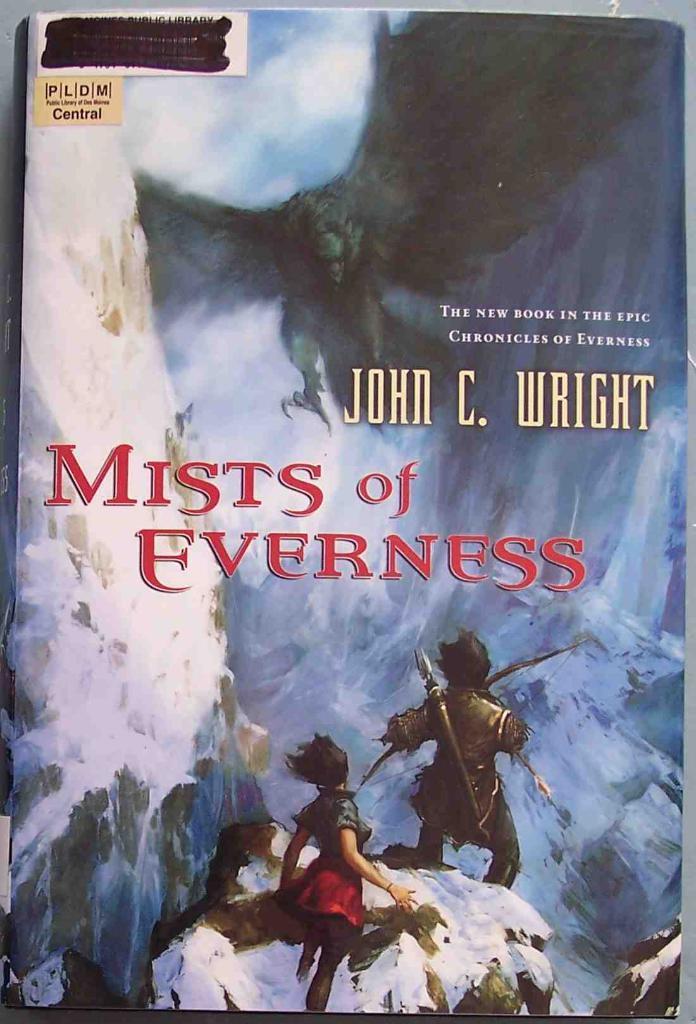Can you describe this image briefly? In this image I can see a book. And on the cover page of the book there are animated pictures and some text. 